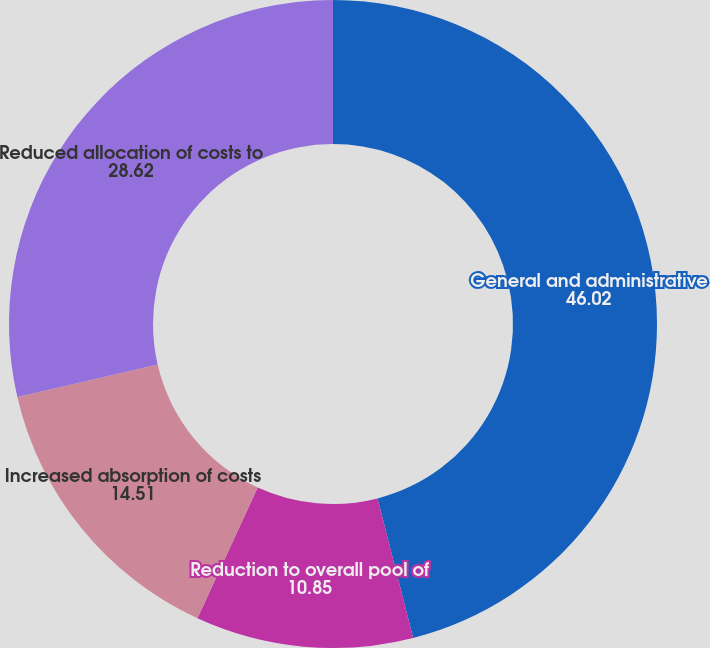<chart> <loc_0><loc_0><loc_500><loc_500><pie_chart><fcel>General and administrative<fcel>Reduction to overall pool of<fcel>Increased absorption of costs<fcel>Reduced allocation of costs to<nl><fcel>46.02%<fcel>10.85%<fcel>14.51%<fcel>28.62%<nl></chart> 